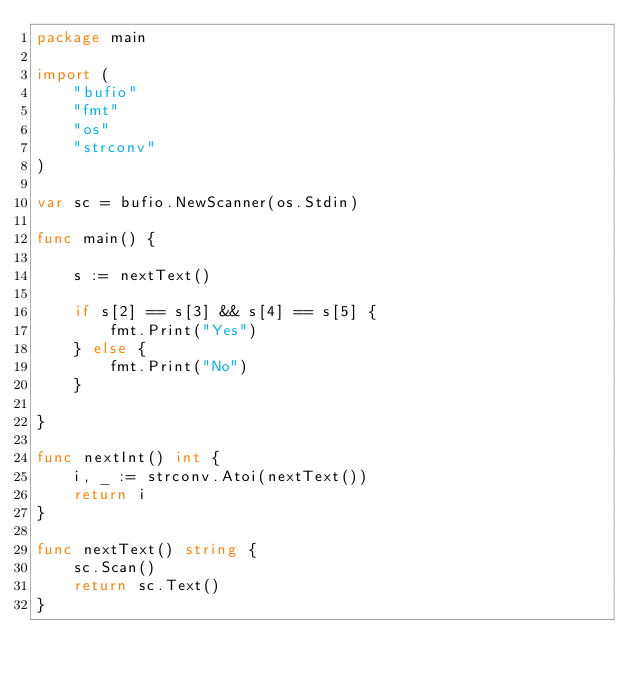Convert code to text. <code><loc_0><loc_0><loc_500><loc_500><_Go_>package main

import (
	"bufio"
	"fmt"
	"os"
	"strconv"
)

var sc = bufio.NewScanner(os.Stdin)

func main() {

	s := nextText()

	if s[2] == s[3] && s[4] == s[5] {
		fmt.Print("Yes")
	} else {
		fmt.Print("No")
	}

}

func nextInt() int {
	i, _ := strconv.Atoi(nextText())
	return i
}

func nextText() string {
	sc.Scan()
	return sc.Text()
}
</code> 